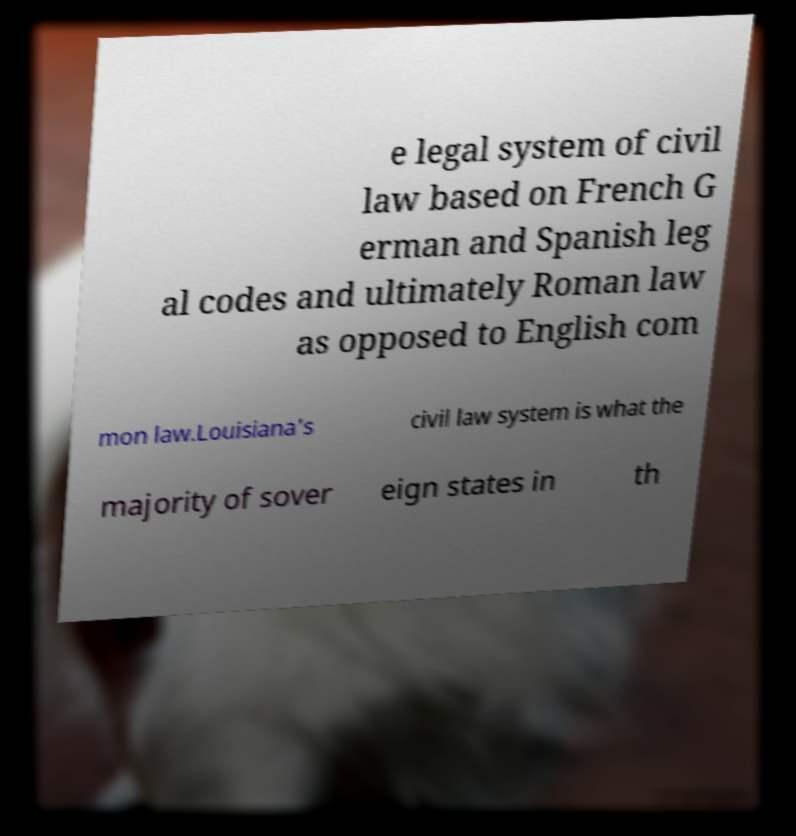What messages or text are displayed in this image? I need them in a readable, typed format. e legal system of civil law based on French G erman and Spanish leg al codes and ultimately Roman law as opposed to English com mon law.Louisiana's civil law system is what the majority of sover eign states in th 